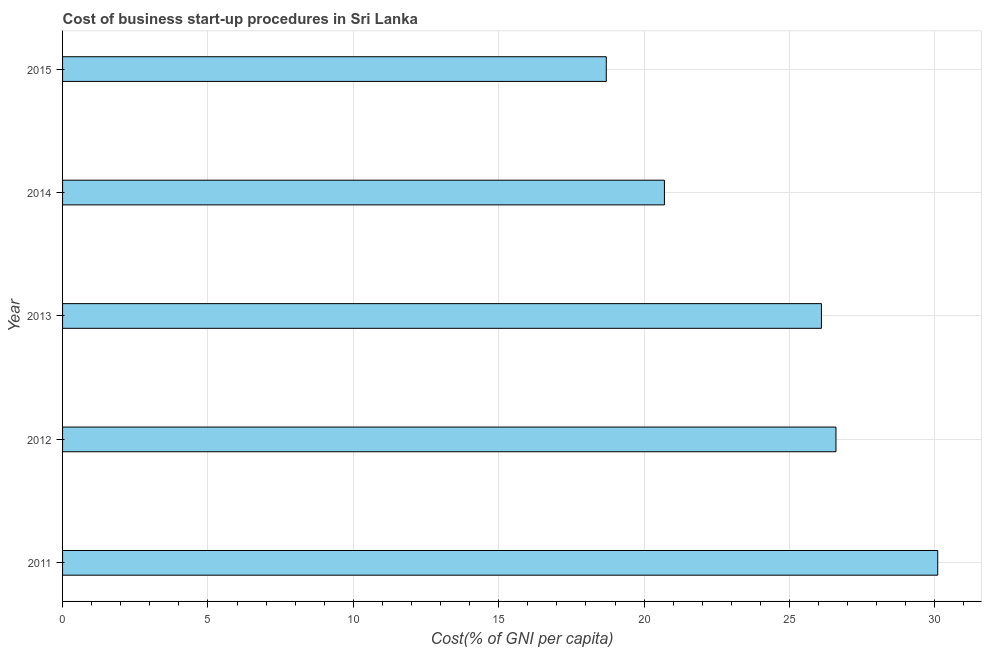Does the graph contain grids?
Your response must be concise. Yes. What is the title of the graph?
Offer a terse response. Cost of business start-up procedures in Sri Lanka. What is the label or title of the X-axis?
Your answer should be very brief. Cost(% of GNI per capita). What is the cost of business startup procedures in 2011?
Provide a short and direct response. 30.1. Across all years, what is the maximum cost of business startup procedures?
Provide a short and direct response. 30.1. Across all years, what is the minimum cost of business startup procedures?
Ensure brevity in your answer.  18.7. In which year was the cost of business startup procedures minimum?
Your answer should be very brief. 2015. What is the sum of the cost of business startup procedures?
Give a very brief answer. 122.2. What is the average cost of business startup procedures per year?
Your answer should be compact. 24.44. What is the median cost of business startup procedures?
Your response must be concise. 26.1. In how many years, is the cost of business startup procedures greater than 20 %?
Provide a short and direct response. 4. Do a majority of the years between 2015 and 2012 (inclusive) have cost of business startup procedures greater than 11 %?
Your response must be concise. Yes. What is the ratio of the cost of business startup procedures in 2011 to that in 2015?
Ensure brevity in your answer.  1.61. Is the sum of the cost of business startup procedures in 2013 and 2015 greater than the maximum cost of business startup procedures across all years?
Offer a terse response. Yes. What is the difference between the highest and the lowest cost of business startup procedures?
Provide a succinct answer. 11.4. In how many years, is the cost of business startup procedures greater than the average cost of business startup procedures taken over all years?
Ensure brevity in your answer.  3. Are all the bars in the graph horizontal?
Offer a terse response. Yes. What is the difference between two consecutive major ticks on the X-axis?
Provide a succinct answer. 5. What is the Cost(% of GNI per capita) of 2011?
Provide a succinct answer. 30.1. What is the Cost(% of GNI per capita) of 2012?
Keep it short and to the point. 26.6. What is the Cost(% of GNI per capita) of 2013?
Offer a very short reply. 26.1. What is the Cost(% of GNI per capita) in 2014?
Make the answer very short. 20.7. What is the Cost(% of GNI per capita) in 2015?
Offer a very short reply. 18.7. What is the difference between the Cost(% of GNI per capita) in 2011 and 2014?
Give a very brief answer. 9.4. What is the difference between the Cost(% of GNI per capita) in 2012 and 2013?
Provide a succinct answer. 0.5. What is the difference between the Cost(% of GNI per capita) in 2012 and 2014?
Offer a very short reply. 5.9. What is the difference between the Cost(% of GNI per capita) in 2013 and 2015?
Your answer should be compact. 7.4. What is the difference between the Cost(% of GNI per capita) in 2014 and 2015?
Make the answer very short. 2. What is the ratio of the Cost(% of GNI per capita) in 2011 to that in 2012?
Your answer should be compact. 1.13. What is the ratio of the Cost(% of GNI per capita) in 2011 to that in 2013?
Ensure brevity in your answer.  1.15. What is the ratio of the Cost(% of GNI per capita) in 2011 to that in 2014?
Make the answer very short. 1.45. What is the ratio of the Cost(% of GNI per capita) in 2011 to that in 2015?
Your answer should be very brief. 1.61. What is the ratio of the Cost(% of GNI per capita) in 2012 to that in 2013?
Your response must be concise. 1.02. What is the ratio of the Cost(% of GNI per capita) in 2012 to that in 2014?
Your response must be concise. 1.28. What is the ratio of the Cost(% of GNI per capita) in 2012 to that in 2015?
Ensure brevity in your answer.  1.42. What is the ratio of the Cost(% of GNI per capita) in 2013 to that in 2014?
Make the answer very short. 1.26. What is the ratio of the Cost(% of GNI per capita) in 2013 to that in 2015?
Your answer should be compact. 1.4. What is the ratio of the Cost(% of GNI per capita) in 2014 to that in 2015?
Your answer should be very brief. 1.11. 